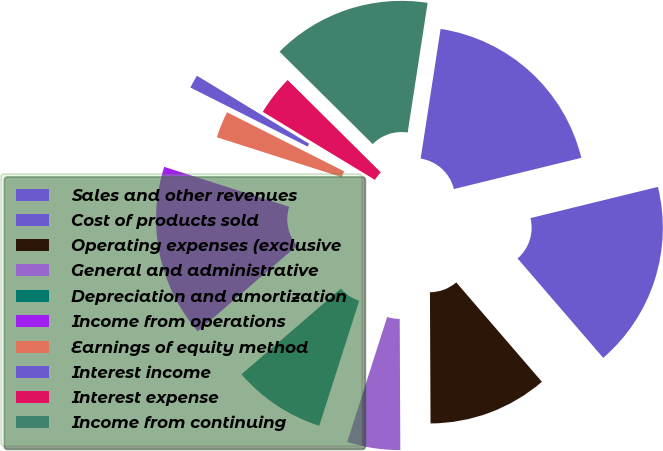<chart> <loc_0><loc_0><loc_500><loc_500><pie_chart><fcel>Sales and other revenues<fcel>Cost of products sold<fcel>Operating expenses (exclusive<fcel>General and administrative<fcel>Depreciation and amortization<fcel>Income from operations<fcel>Earnings of equity method<fcel>Interest income<fcel>Interest expense<fcel>Income from continuing<nl><fcel>18.75%<fcel>17.5%<fcel>11.25%<fcel>5.0%<fcel>8.75%<fcel>16.25%<fcel>2.5%<fcel>1.25%<fcel>3.75%<fcel>15.0%<nl></chart> 